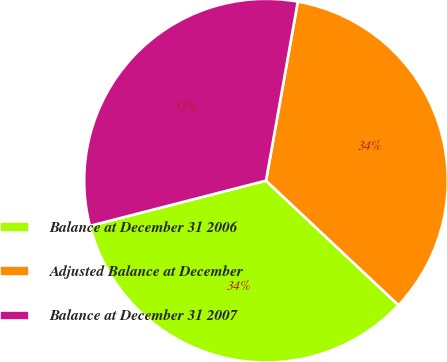Convert chart to OTSL. <chart><loc_0><loc_0><loc_500><loc_500><pie_chart><fcel>Balance at December 31 2006<fcel>Adjusted Balance at December<fcel>Balance at December 31 2007<nl><fcel>33.99%<fcel>34.21%<fcel>31.8%<nl></chart> 